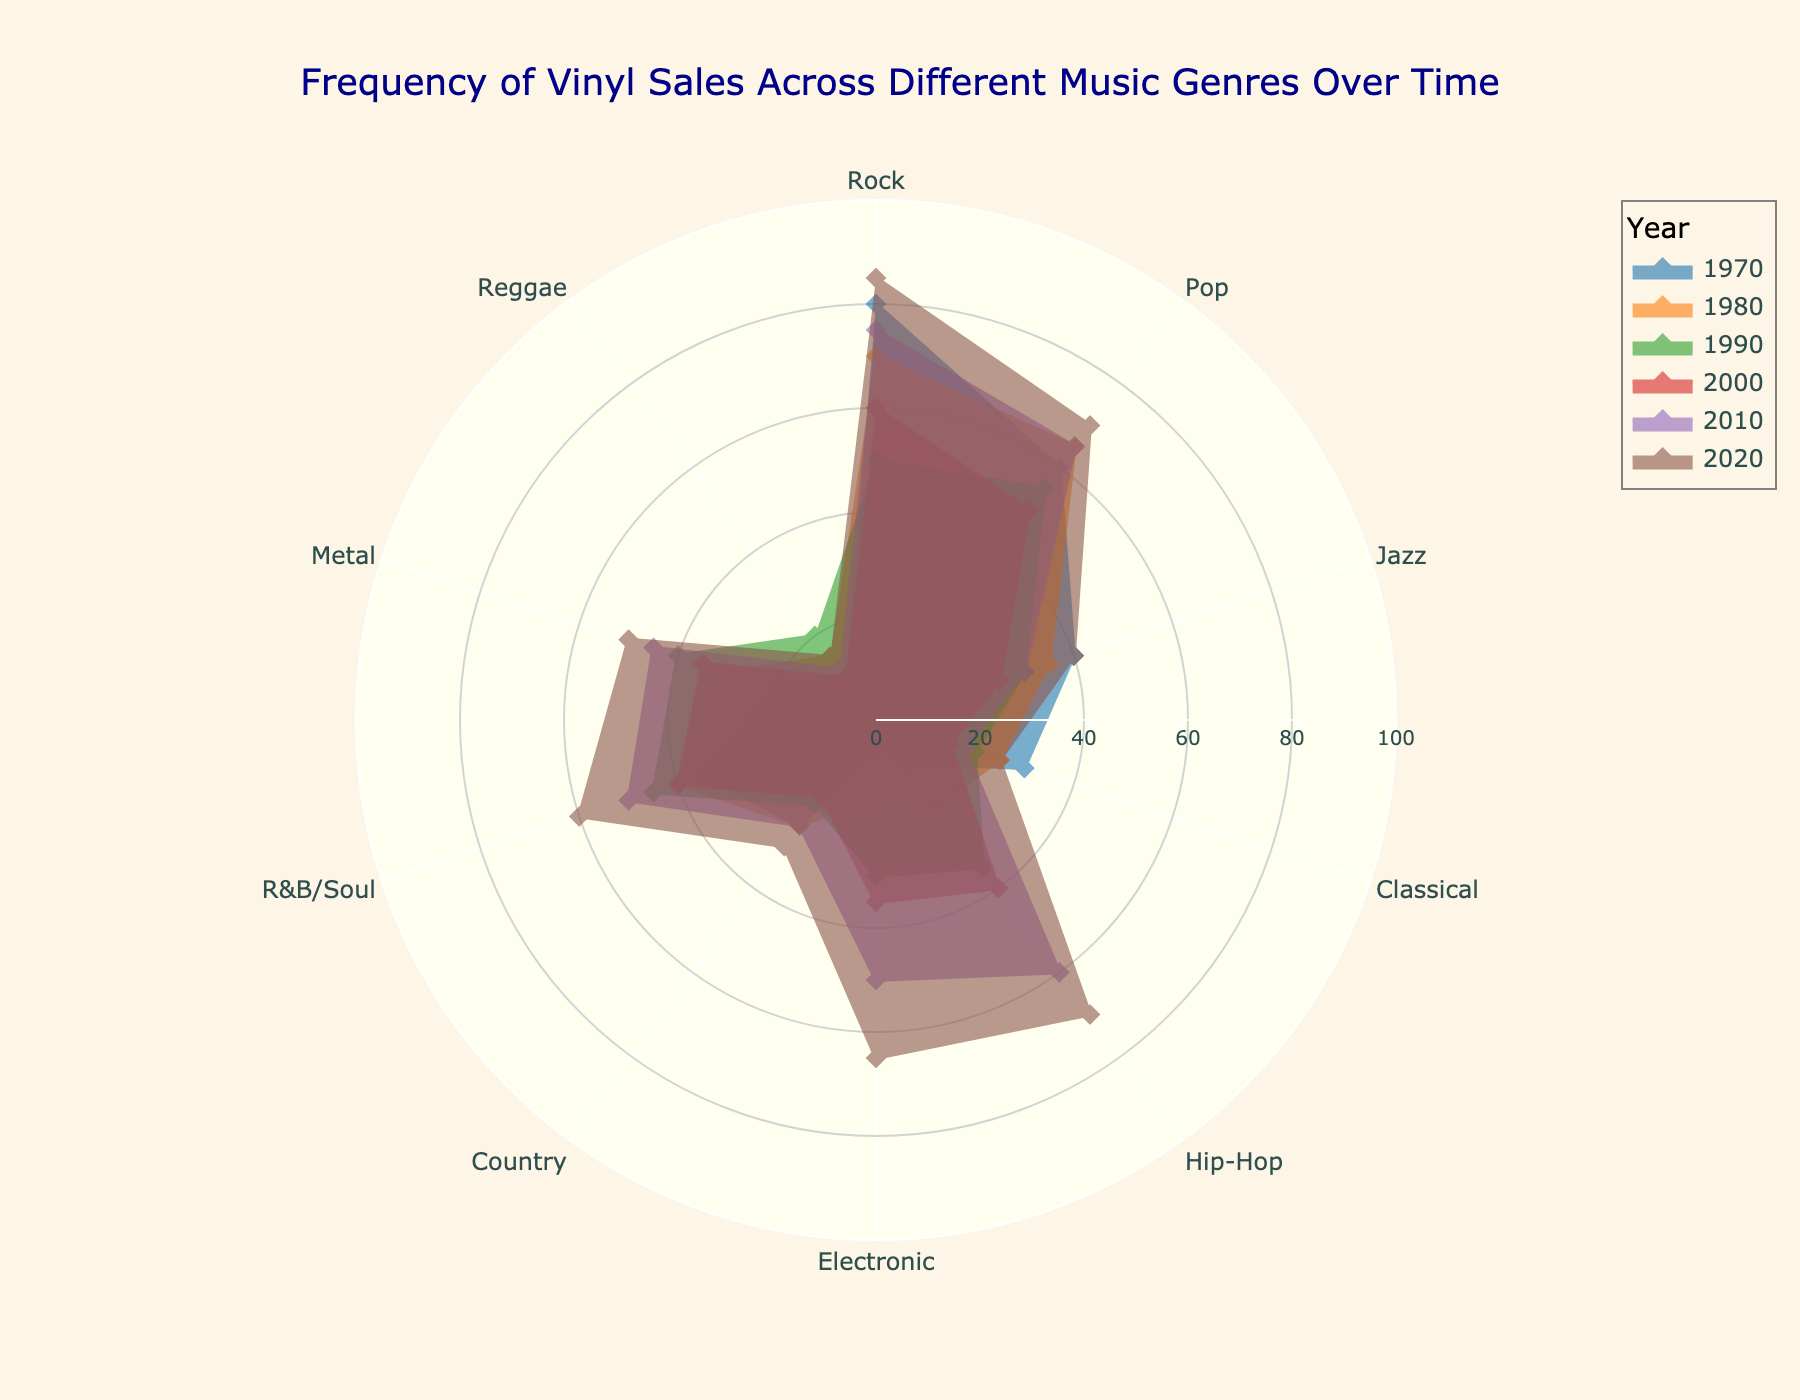What genre had the highest frequency of vinyl sales in 1980? By looking at the radar chart, we can find the data point with the highest value for the year 1980.
Answer: Rock How did the frequency of Hip-Hop vinyl sales change from 1970 to 2020? We need to trace the data points for Hip-Hop from 1970 to 2020 and observe the pattern. The values increase from 1970 (10) to 2020 (70).
Answer: Increased Which genre shows the largest increase in vinyl sales from 2000 to 2020? For each genre, calculate the difference between the 2020 and 2000 values. The genre with the highest positive difference is the one that shows the largest increase.
Answer: Electronic What is the average frequency of vinyl sales for Jazz across the six years shown? Sum the vinyl sales for Jazz (40 + 35 + 30 + 25 + 30 + 40) and divide by the number of years (6). The average is (200 / 6).
Answer: 33.33 Which year had the lowest overall frequency of vinyl sales for Reggae? By comparing the radar chart data points for Reggae across different years, identify the year with the lowest value.
Answer: 2000 Which genre consistently maintained or increased its vinyl sales from 2000 to 2020? Look at the radar chart and check each genre's pattern from 2000 to 2020. Identify the genre that did not decrease in any of these years.
Answer: Hip-Hop How do the 2020 vinyl sales for R&B/Soul compare to Pop? Compare the 2020 data points for R&B/Soul (60) and Pop (70) on the radar chart. Determine which is higher or if they are equal.
Answer: Pop is greater What is the sum of the vinyl sales for all genres in 2010? Sum the vinyl sales for all genres in the year 2010 (75 + 65 + 30 + 18 + 60 + 50 + 25 + 50 + 45 + 12).
Answer: 430 Which genre had a significant drop in vinyl sales in 2000 compared to the previous decades? Identify the genre showing a noticeable reduction in sales by comparing data points over 1970, 1980, 1990 to 2000.
Answer: Jazz 